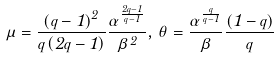Convert formula to latex. <formula><loc_0><loc_0><loc_500><loc_500>\mu = \frac { \left ( q - 1 \right ) ^ { 2 } } { q \left ( 2 q - 1 \right ) } \frac { \alpha ^ { \frac { 2 q - 1 } { q - 1 } } } { \beta ^ { 2 } } , \, \theta = \frac { \alpha ^ { \frac { q } { q - 1 } } } { \beta } \frac { \left ( 1 - q \right ) } { q }</formula> 